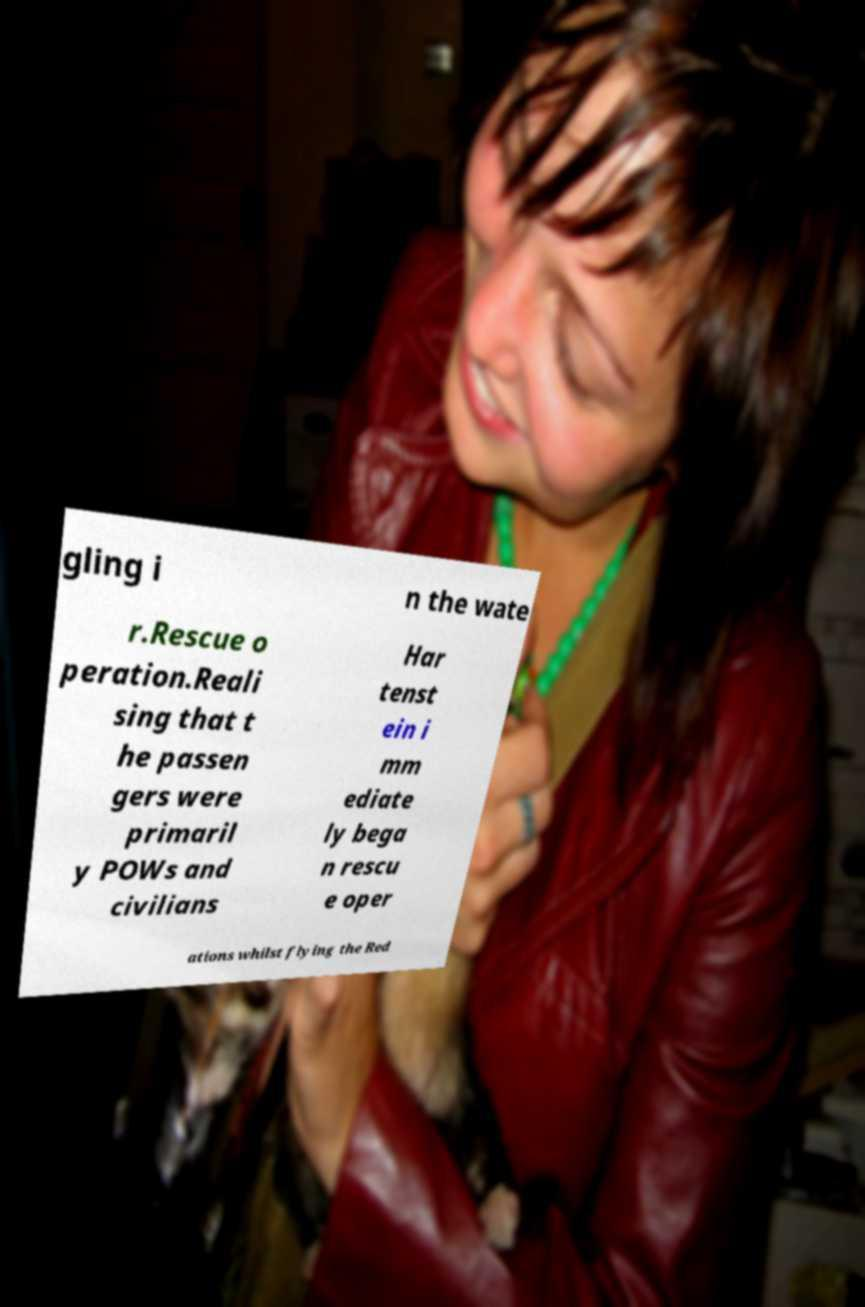There's text embedded in this image that I need extracted. Can you transcribe it verbatim? gling i n the wate r.Rescue o peration.Reali sing that t he passen gers were primaril y POWs and civilians Har tenst ein i mm ediate ly bega n rescu e oper ations whilst flying the Red 